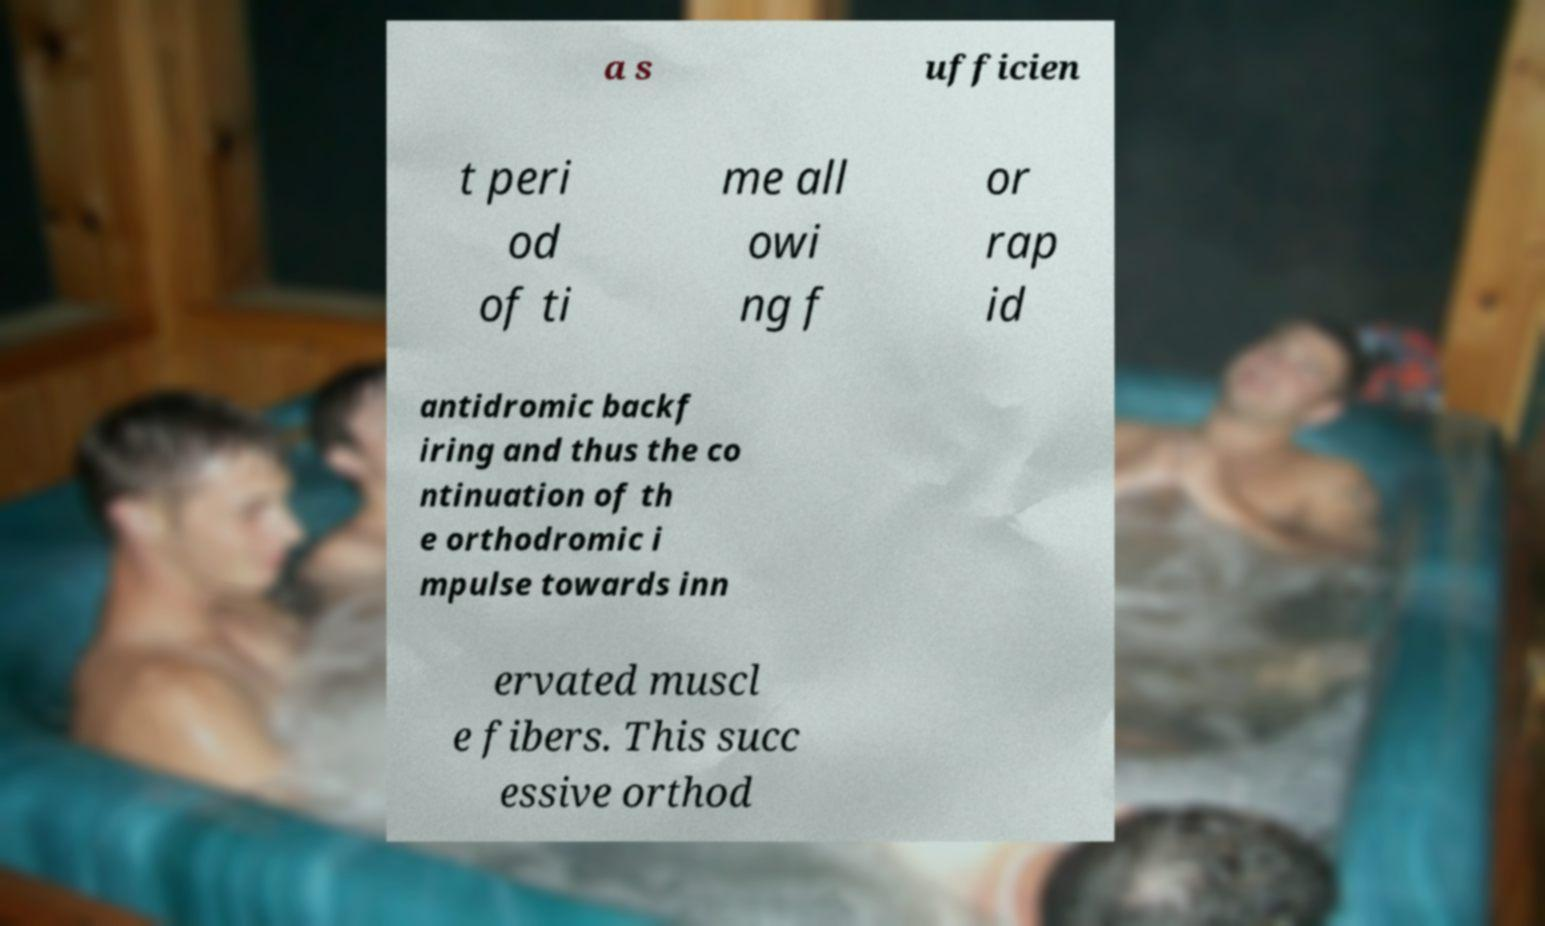There's text embedded in this image that I need extracted. Can you transcribe it verbatim? a s ufficien t peri od of ti me all owi ng f or rap id antidromic backf iring and thus the co ntinuation of th e orthodromic i mpulse towards inn ervated muscl e fibers. This succ essive orthod 